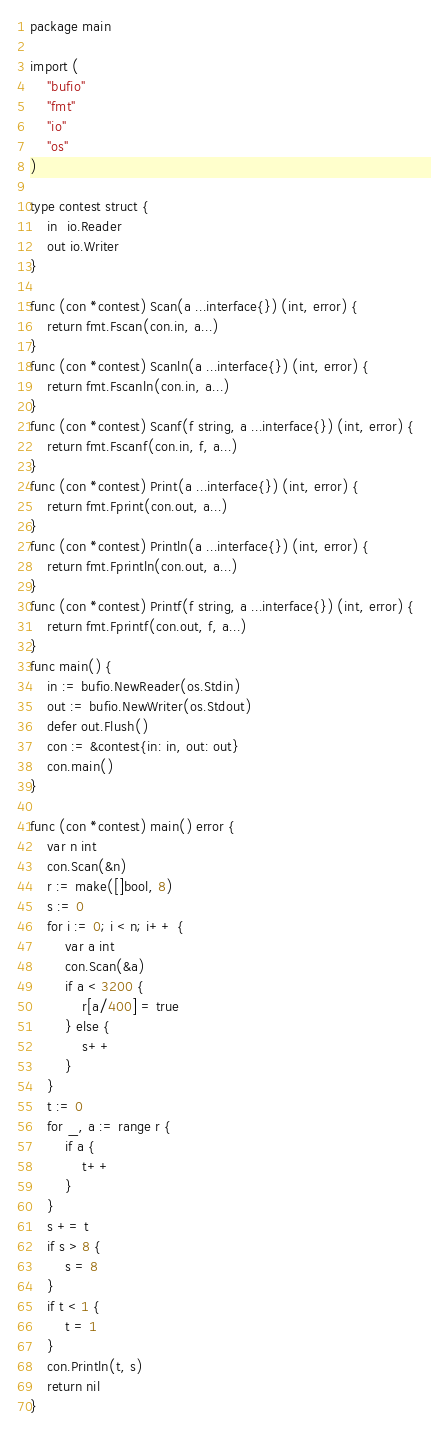Convert code to text. <code><loc_0><loc_0><loc_500><loc_500><_Go_>package main

import (
	"bufio"
	"fmt"
	"io"
	"os"
)

type contest struct {
	in  io.Reader
	out io.Writer
}

func (con *contest) Scan(a ...interface{}) (int, error) {
	return fmt.Fscan(con.in, a...)
}
func (con *contest) Scanln(a ...interface{}) (int, error) {
	return fmt.Fscanln(con.in, a...)
}
func (con *contest) Scanf(f string, a ...interface{}) (int, error) {
	return fmt.Fscanf(con.in, f, a...)
}
func (con *contest) Print(a ...interface{}) (int, error) {
	return fmt.Fprint(con.out, a...)
}
func (con *contest) Println(a ...interface{}) (int, error) {
	return fmt.Fprintln(con.out, a...)
}
func (con *contest) Printf(f string, a ...interface{}) (int, error) {
	return fmt.Fprintf(con.out, f, a...)
}
func main() {
	in := bufio.NewReader(os.Stdin)
	out := bufio.NewWriter(os.Stdout)
	defer out.Flush()
	con := &contest{in: in, out: out}
	con.main()
}

func (con *contest) main() error {
	var n int
	con.Scan(&n)
	r := make([]bool, 8)
	s := 0
	for i := 0; i < n; i++ {
		var a int
		con.Scan(&a)
		if a < 3200 {
			r[a/400] = true
		} else {
			s++
		}
	}
	t := 0
	for _, a := range r {
		if a {
			t++
		}
	}
	s += t
	if s > 8 {
		s = 8
	}
	if t < 1 {
		t = 1
	}
	con.Println(t, s)
	return nil
}
</code> 